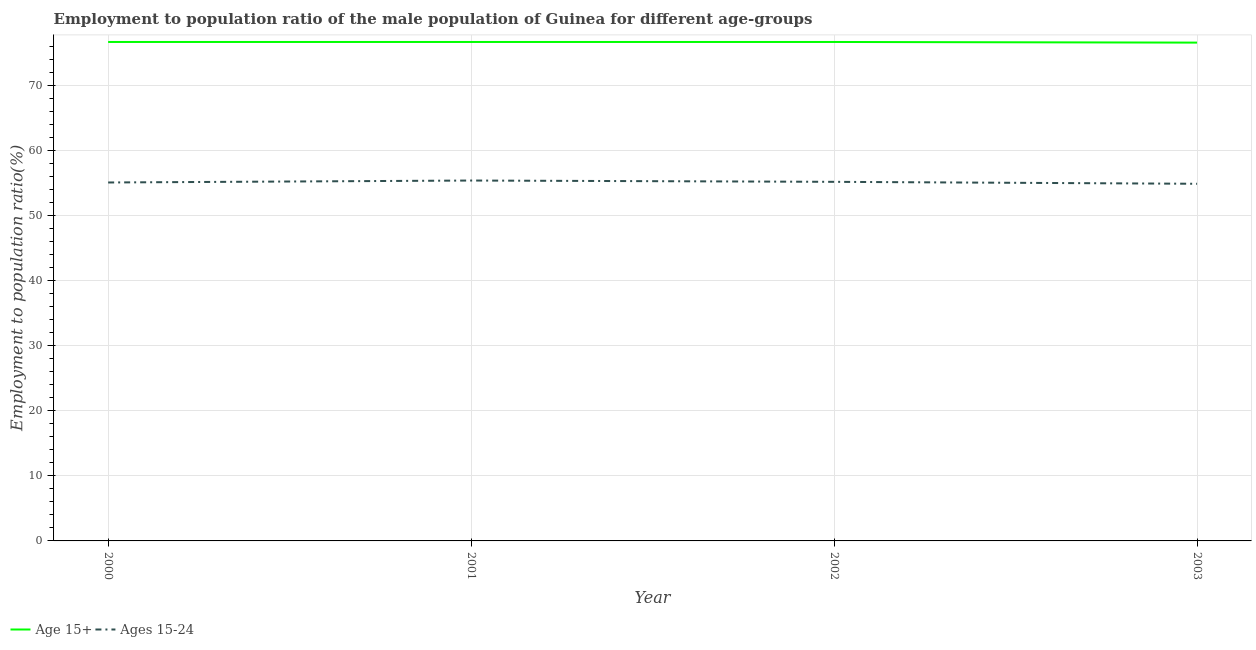How many different coloured lines are there?
Your response must be concise. 2. Does the line corresponding to employment to population ratio(age 15-24) intersect with the line corresponding to employment to population ratio(age 15+)?
Your answer should be compact. No. What is the employment to population ratio(age 15-24) in 2002?
Make the answer very short. 55.2. Across all years, what is the maximum employment to population ratio(age 15+)?
Provide a succinct answer. 76.7. Across all years, what is the minimum employment to population ratio(age 15+)?
Offer a very short reply. 76.6. In which year was the employment to population ratio(age 15-24) maximum?
Keep it short and to the point. 2001. What is the total employment to population ratio(age 15+) in the graph?
Offer a terse response. 306.7. What is the difference between the employment to population ratio(age 15-24) in 2002 and the employment to population ratio(age 15+) in 2000?
Make the answer very short. -21.5. What is the average employment to population ratio(age 15+) per year?
Your response must be concise. 76.67. In the year 2001, what is the difference between the employment to population ratio(age 15+) and employment to population ratio(age 15-24)?
Offer a terse response. 21.3. What is the ratio of the employment to population ratio(age 15-24) in 2000 to that in 2002?
Provide a succinct answer. 1. Is the difference between the employment to population ratio(age 15+) in 2000 and 2002 greater than the difference between the employment to population ratio(age 15-24) in 2000 and 2002?
Your answer should be very brief. Yes. What is the difference between the highest and the second highest employment to population ratio(age 15+)?
Provide a succinct answer. 0. What is the difference between the highest and the lowest employment to population ratio(age 15+)?
Your answer should be compact. 0.1. In how many years, is the employment to population ratio(age 15+) greater than the average employment to population ratio(age 15+) taken over all years?
Provide a succinct answer. 3. Is the sum of the employment to population ratio(age 15+) in 2001 and 2003 greater than the maximum employment to population ratio(age 15-24) across all years?
Offer a terse response. Yes. Is the employment to population ratio(age 15-24) strictly greater than the employment to population ratio(age 15+) over the years?
Make the answer very short. No. Is the employment to population ratio(age 15+) strictly less than the employment to population ratio(age 15-24) over the years?
Give a very brief answer. No. What is the difference between two consecutive major ticks on the Y-axis?
Ensure brevity in your answer.  10. Are the values on the major ticks of Y-axis written in scientific E-notation?
Offer a terse response. No. Does the graph contain grids?
Provide a succinct answer. Yes. How many legend labels are there?
Offer a terse response. 2. What is the title of the graph?
Provide a short and direct response. Employment to population ratio of the male population of Guinea for different age-groups. Does "Female labourers" appear as one of the legend labels in the graph?
Make the answer very short. No. What is the label or title of the Y-axis?
Ensure brevity in your answer.  Employment to population ratio(%). What is the Employment to population ratio(%) of Age 15+ in 2000?
Make the answer very short. 76.7. What is the Employment to population ratio(%) in Ages 15-24 in 2000?
Offer a terse response. 55.1. What is the Employment to population ratio(%) of Age 15+ in 2001?
Your answer should be very brief. 76.7. What is the Employment to population ratio(%) in Ages 15-24 in 2001?
Provide a short and direct response. 55.4. What is the Employment to population ratio(%) of Age 15+ in 2002?
Keep it short and to the point. 76.7. What is the Employment to population ratio(%) in Ages 15-24 in 2002?
Keep it short and to the point. 55.2. What is the Employment to population ratio(%) in Age 15+ in 2003?
Offer a very short reply. 76.6. What is the Employment to population ratio(%) in Ages 15-24 in 2003?
Ensure brevity in your answer.  54.9. Across all years, what is the maximum Employment to population ratio(%) in Age 15+?
Your answer should be very brief. 76.7. Across all years, what is the maximum Employment to population ratio(%) in Ages 15-24?
Provide a succinct answer. 55.4. Across all years, what is the minimum Employment to population ratio(%) of Age 15+?
Make the answer very short. 76.6. Across all years, what is the minimum Employment to population ratio(%) of Ages 15-24?
Ensure brevity in your answer.  54.9. What is the total Employment to population ratio(%) in Age 15+ in the graph?
Ensure brevity in your answer.  306.7. What is the total Employment to population ratio(%) of Ages 15-24 in the graph?
Ensure brevity in your answer.  220.6. What is the difference between the Employment to population ratio(%) in Age 15+ in 2000 and that in 2001?
Provide a short and direct response. 0. What is the difference between the Employment to population ratio(%) of Ages 15-24 in 2000 and that in 2001?
Keep it short and to the point. -0.3. What is the difference between the Employment to population ratio(%) of Age 15+ in 2000 and that in 2002?
Ensure brevity in your answer.  0. What is the difference between the Employment to population ratio(%) in Ages 15-24 in 2000 and that in 2002?
Your response must be concise. -0.1. What is the difference between the Employment to population ratio(%) in Age 15+ in 2001 and that in 2002?
Make the answer very short. 0. What is the difference between the Employment to population ratio(%) in Ages 15-24 in 2001 and that in 2002?
Offer a terse response. 0.2. What is the difference between the Employment to population ratio(%) in Age 15+ in 2002 and that in 2003?
Give a very brief answer. 0.1. What is the difference between the Employment to population ratio(%) in Ages 15-24 in 2002 and that in 2003?
Offer a terse response. 0.3. What is the difference between the Employment to population ratio(%) in Age 15+ in 2000 and the Employment to population ratio(%) in Ages 15-24 in 2001?
Ensure brevity in your answer.  21.3. What is the difference between the Employment to population ratio(%) in Age 15+ in 2000 and the Employment to population ratio(%) in Ages 15-24 in 2002?
Your answer should be very brief. 21.5. What is the difference between the Employment to population ratio(%) in Age 15+ in 2000 and the Employment to population ratio(%) in Ages 15-24 in 2003?
Keep it short and to the point. 21.8. What is the difference between the Employment to population ratio(%) of Age 15+ in 2001 and the Employment to population ratio(%) of Ages 15-24 in 2003?
Ensure brevity in your answer.  21.8. What is the difference between the Employment to population ratio(%) in Age 15+ in 2002 and the Employment to population ratio(%) in Ages 15-24 in 2003?
Give a very brief answer. 21.8. What is the average Employment to population ratio(%) in Age 15+ per year?
Your response must be concise. 76.67. What is the average Employment to population ratio(%) in Ages 15-24 per year?
Provide a short and direct response. 55.15. In the year 2000, what is the difference between the Employment to population ratio(%) of Age 15+ and Employment to population ratio(%) of Ages 15-24?
Your response must be concise. 21.6. In the year 2001, what is the difference between the Employment to population ratio(%) in Age 15+ and Employment to population ratio(%) in Ages 15-24?
Make the answer very short. 21.3. In the year 2002, what is the difference between the Employment to population ratio(%) in Age 15+ and Employment to population ratio(%) in Ages 15-24?
Your response must be concise. 21.5. In the year 2003, what is the difference between the Employment to population ratio(%) of Age 15+ and Employment to population ratio(%) of Ages 15-24?
Provide a short and direct response. 21.7. What is the ratio of the Employment to population ratio(%) in Age 15+ in 2000 to that in 2001?
Your answer should be very brief. 1. What is the ratio of the Employment to population ratio(%) in Ages 15-24 in 2000 to that in 2001?
Ensure brevity in your answer.  0.99. What is the ratio of the Employment to population ratio(%) of Age 15+ in 2000 to that in 2002?
Provide a short and direct response. 1. What is the ratio of the Employment to population ratio(%) of Ages 15-24 in 2000 to that in 2002?
Make the answer very short. 1. What is the ratio of the Employment to population ratio(%) in Age 15+ in 2000 to that in 2003?
Offer a terse response. 1. What is the ratio of the Employment to population ratio(%) of Ages 15-24 in 2000 to that in 2003?
Provide a short and direct response. 1. What is the ratio of the Employment to population ratio(%) of Ages 15-24 in 2001 to that in 2002?
Your answer should be very brief. 1. What is the ratio of the Employment to population ratio(%) of Age 15+ in 2001 to that in 2003?
Keep it short and to the point. 1. What is the ratio of the Employment to population ratio(%) in Ages 15-24 in 2001 to that in 2003?
Provide a short and direct response. 1.01. What is the ratio of the Employment to population ratio(%) of Ages 15-24 in 2002 to that in 2003?
Make the answer very short. 1.01. 